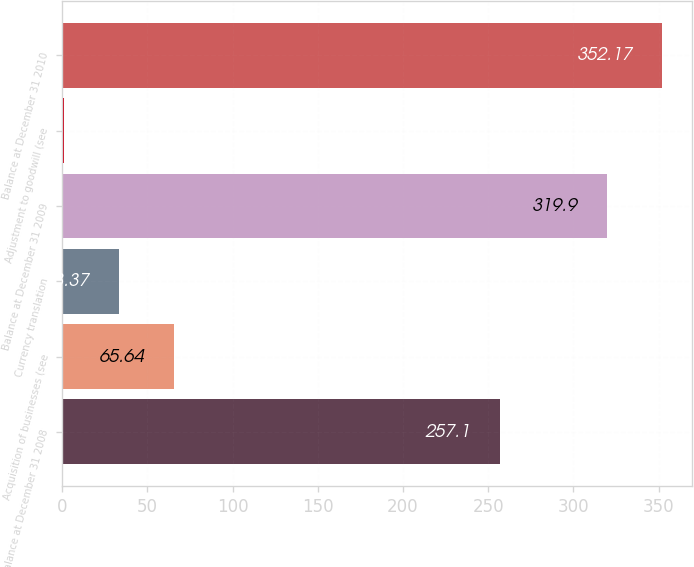Convert chart. <chart><loc_0><loc_0><loc_500><loc_500><bar_chart><fcel>Balance at December 31 2008<fcel>Acquisition of businesses (see<fcel>Currency translation<fcel>Balance at December 31 2009<fcel>Adjustment to goodwill (see<fcel>Balance at December 31 2010<nl><fcel>257.1<fcel>65.64<fcel>33.37<fcel>319.9<fcel>1.1<fcel>352.17<nl></chart> 